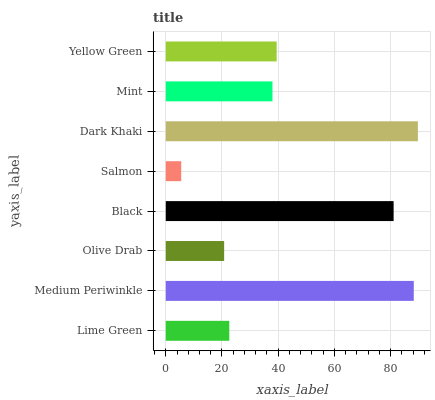Is Salmon the minimum?
Answer yes or no. Yes. Is Dark Khaki the maximum?
Answer yes or no. Yes. Is Medium Periwinkle the minimum?
Answer yes or no. No. Is Medium Periwinkle the maximum?
Answer yes or no. No. Is Medium Periwinkle greater than Lime Green?
Answer yes or no. Yes. Is Lime Green less than Medium Periwinkle?
Answer yes or no. Yes. Is Lime Green greater than Medium Periwinkle?
Answer yes or no. No. Is Medium Periwinkle less than Lime Green?
Answer yes or no. No. Is Yellow Green the high median?
Answer yes or no. Yes. Is Mint the low median?
Answer yes or no. Yes. Is Mint the high median?
Answer yes or no. No. Is Dark Khaki the low median?
Answer yes or no. No. 